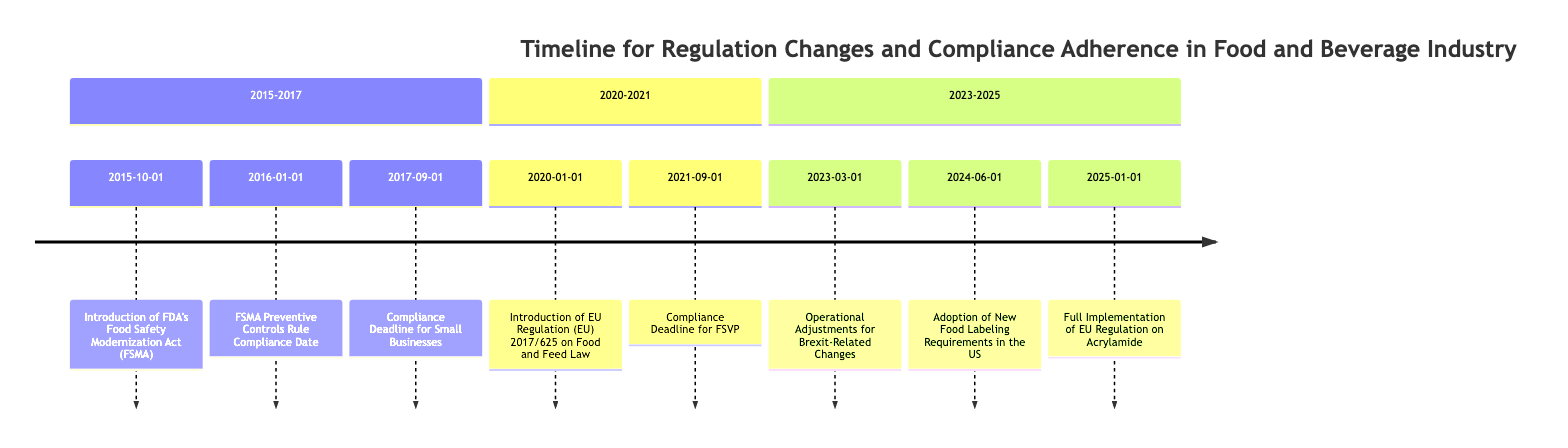What event was introduced on October 1, 2015? The diagram shows that on October 1, 2015, the FDA's Food Safety Modernization Act (FSMA) was introduced.
Answer: FDA's Food Safety Modernization Act (FSMA) What was the compliance date for large companies regarding the FSMA Preventive Controls Rule? According to the diagram, large companies had to comply with the FSMA Preventive Controls Rule starting January 1, 2016.
Answer: January 1, 2016 How many major regulatory events are listed between 2015 and 2025? By counting the events shown in the timeline from 2015 to 2025, there are a total of 8 major regulatory events.
Answer: 8 What event occurred on March 1, 2023? The diagram indicates that on March 1, 2023, operational adjustments were made for Brexit-related changes.
Answer: Operational Adjustments for Brexit-Related Changes Which regulatory change requires adherence to new labeling requirements by June 1, 2024? The timeline specifies that by June 1, 2024, food and beverage companies must adhere to new FDA regulations on nutrition labeling.
Answer: New Food Labeling Requirements in the US What is the compliance deadline for small businesses regarding the FSMA preventive controls rule? The diagram indicates that the compliance deadline for small businesses was September 1, 2017.
Answer: September 1, 2017 What significant change is set for January 1, 2025? According to the timeline, January 1, 2025, marks the full implementation of the EU regulation on acrylamide in food products.
Answer: Full Implementation of EU Regulation on Acrylamide What event took place in September 2021? The diagram shows that in September 2021, the compliance deadline for the FDA's Foreign Supplier Verification Programs (FSVP) took place.
Answer: Compliance Deadline for FSVP Which regulatory change is related to Brexit adjustments? The timeline clearly indicates that the operational adjustments for Brexit-related changes occurred on March 1, 2023.
Answer: Operational Adjustments for Brexit-Related Changes 